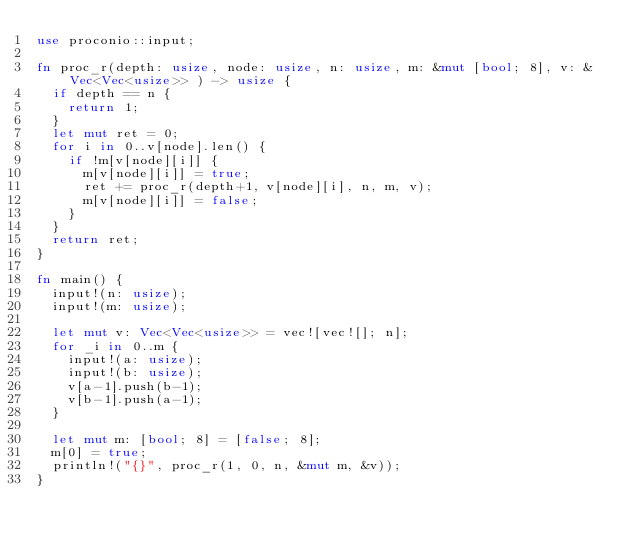Convert code to text. <code><loc_0><loc_0><loc_500><loc_500><_Rust_>use proconio::input;

fn proc_r(depth: usize, node: usize, n: usize, m: &mut [bool; 8], v: &Vec<Vec<usize>> ) -> usize {
	if depth == n {
		return 1;
	}
	let mut ret = 0;
	for i in 0..v[node].len() {
		if !m[v[node][i]] {
			m[v[node][i]] = true;
			ret += proc_r(depth+1, v[node][i], n, m, v);
			m[v[node][i]] = false;
		}
	}
	return ret;
}

fn main() {
	input!(n: usize);
	input!(m: usize);

	let mut v: Vec<Vec<usize>> = vec![vec![]; n];
	for _i in 0..m {
		input!(a: usize);
		input!(b: usize);
		v[a-1].push(b-1);
		v[b-1].push(a-1);
	}

	let mut m: [bool; 8] = [false; 8];
	m[0] = true;
	println!("{}", proc_r(1, 0, n, &mut m, &v));
}
</code> 